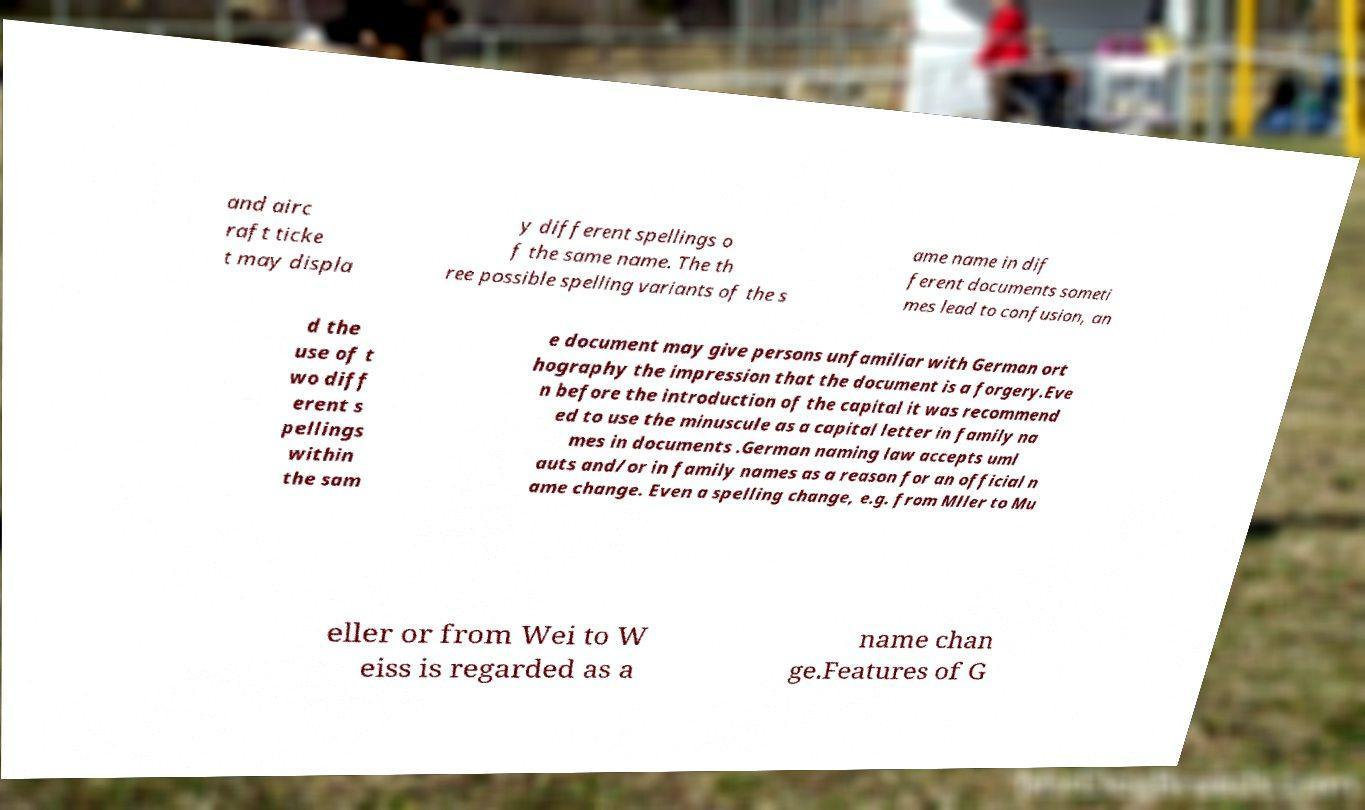Can you accurately transcribe the text from the provided image for me? and airc raft ticke t may displa y different spellings o f the same name. The th ree possible spelling variants of the s ame name in dif ferent documents someti mes lead to confusion, an d the use of t wo diff erent s pellings within the sam e document may give persons unfamiliar with German ort hography the impression that the document is a forgery.Eve n before the introduction of the capital it was recommend ed to use the minuscule as a capital letter in family na mes in documents .German naming law accepts uml auts and/or in family names as a reason for an official n ame change. Even a spelling change, e.g. from Mller to Mu eller or from Wei to W eiss is regarded as a name chan ge.Features of G 